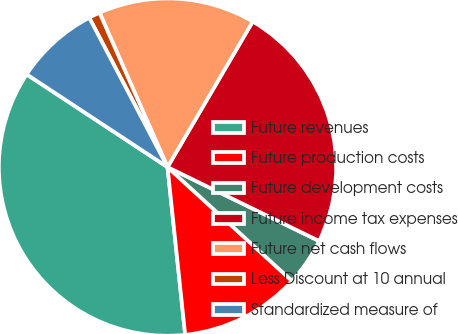Convert chart to OTSL. <chart><loc_0><loc_0><loc_500><loc_500><pie_chart><fcel>Future revenues<fcel>Future production costs<fcel>Future development costs<fcel>Future income tax expenses<fcel>Future net cash flows<fcel>Less Discount at 10 annual<fcel>Standardized measure of<nl><fcel>35.94%<fcel>11.54%<fcel>4.57%<fcel>23.79%<fcel>15.03%<fcel>1.08%<fcel>8.05%<nl></chart> 